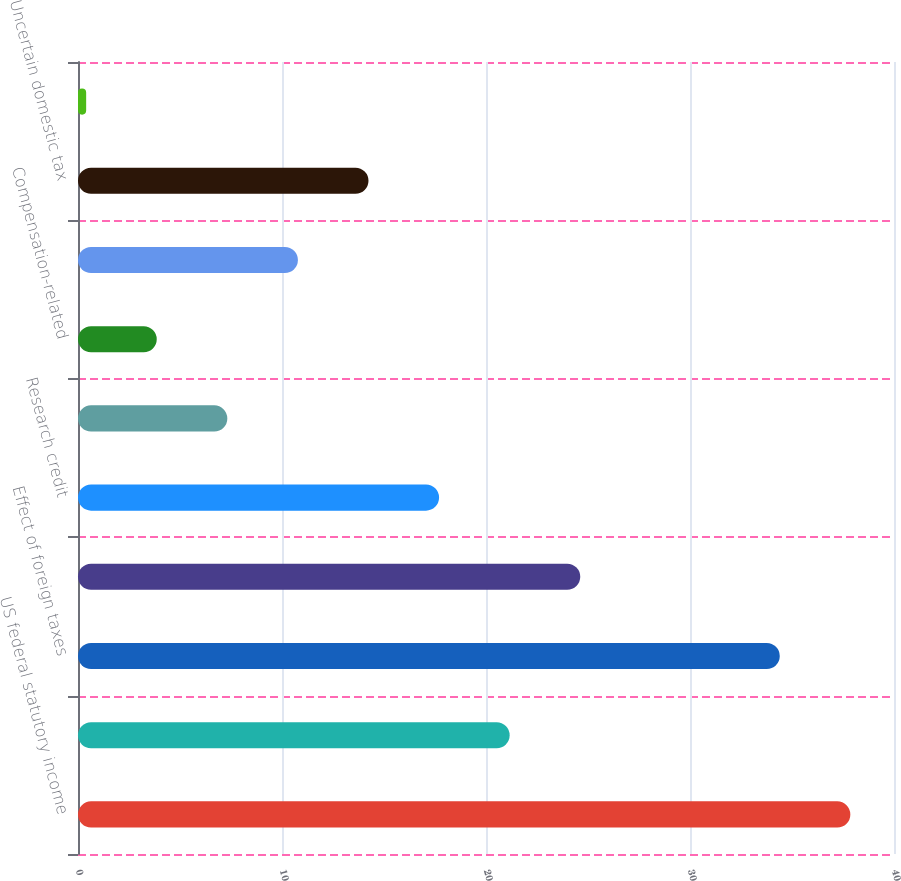Convert chart. <chart><loc_0><loc_0><loc_500><loc_500><bar_chart><fcel>US federal statutory income<fcel>State income taxes net of<fcel>Effect of foreign taxes<fcel>Acquisition-related<fcel>Research credit<fcel>Valuation allowance<fcel>Compensation-related<fcel>Non-deductible expenses<fcel>Uncertain domestic tax<fcel>Other net<nl><fcel>37.86<fcel>21.16<fcel>34.4<fcel>24.62<fcel>17.7<fcel>7.32<fcel>3.86<fcel>10.78<fcel>14.24<fcel>0.4<nl></chart> 